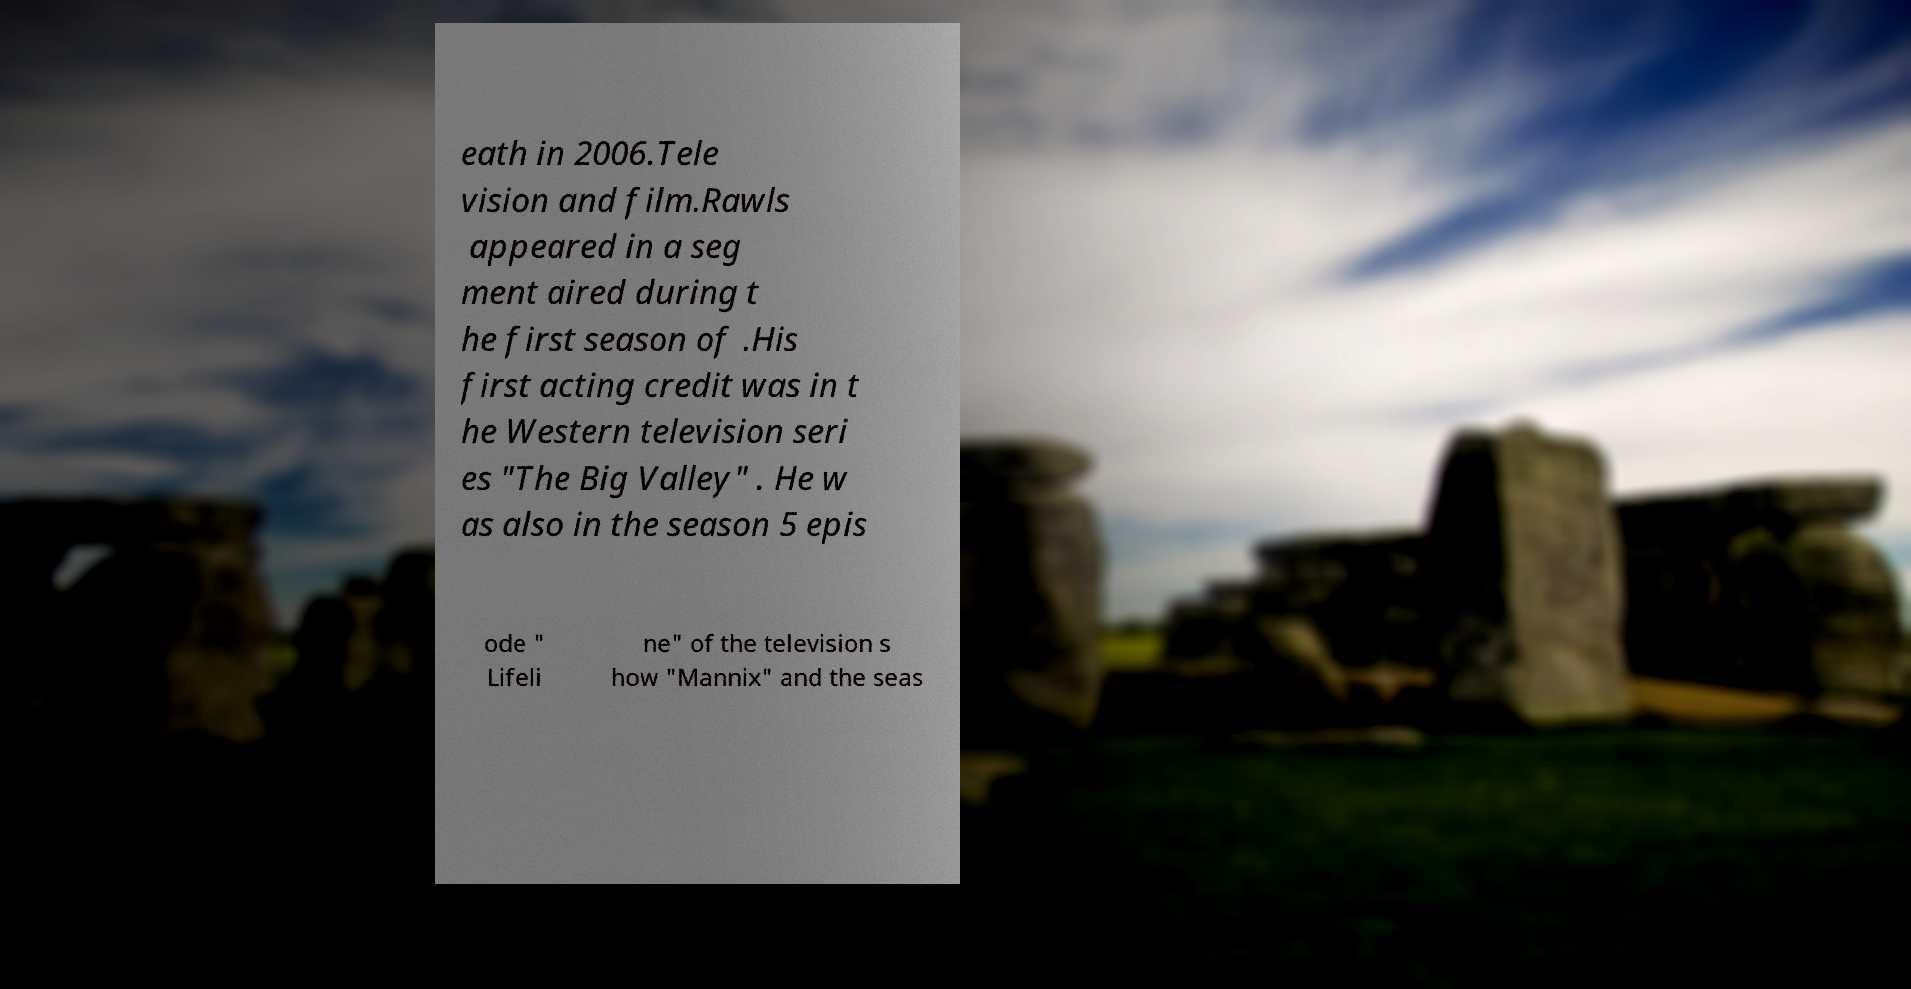Can you accurately transcribe the text from the provided image for me? eath in 2006.Tele vision and film.Rawls appeared in a seg ment aired during t he first season of .His first acting credit was in t he Western television seri es "The Big Valley" . He w as also in the season 5 epis ode " Lifeli ne" of the television s how "Mannix" and the seas 